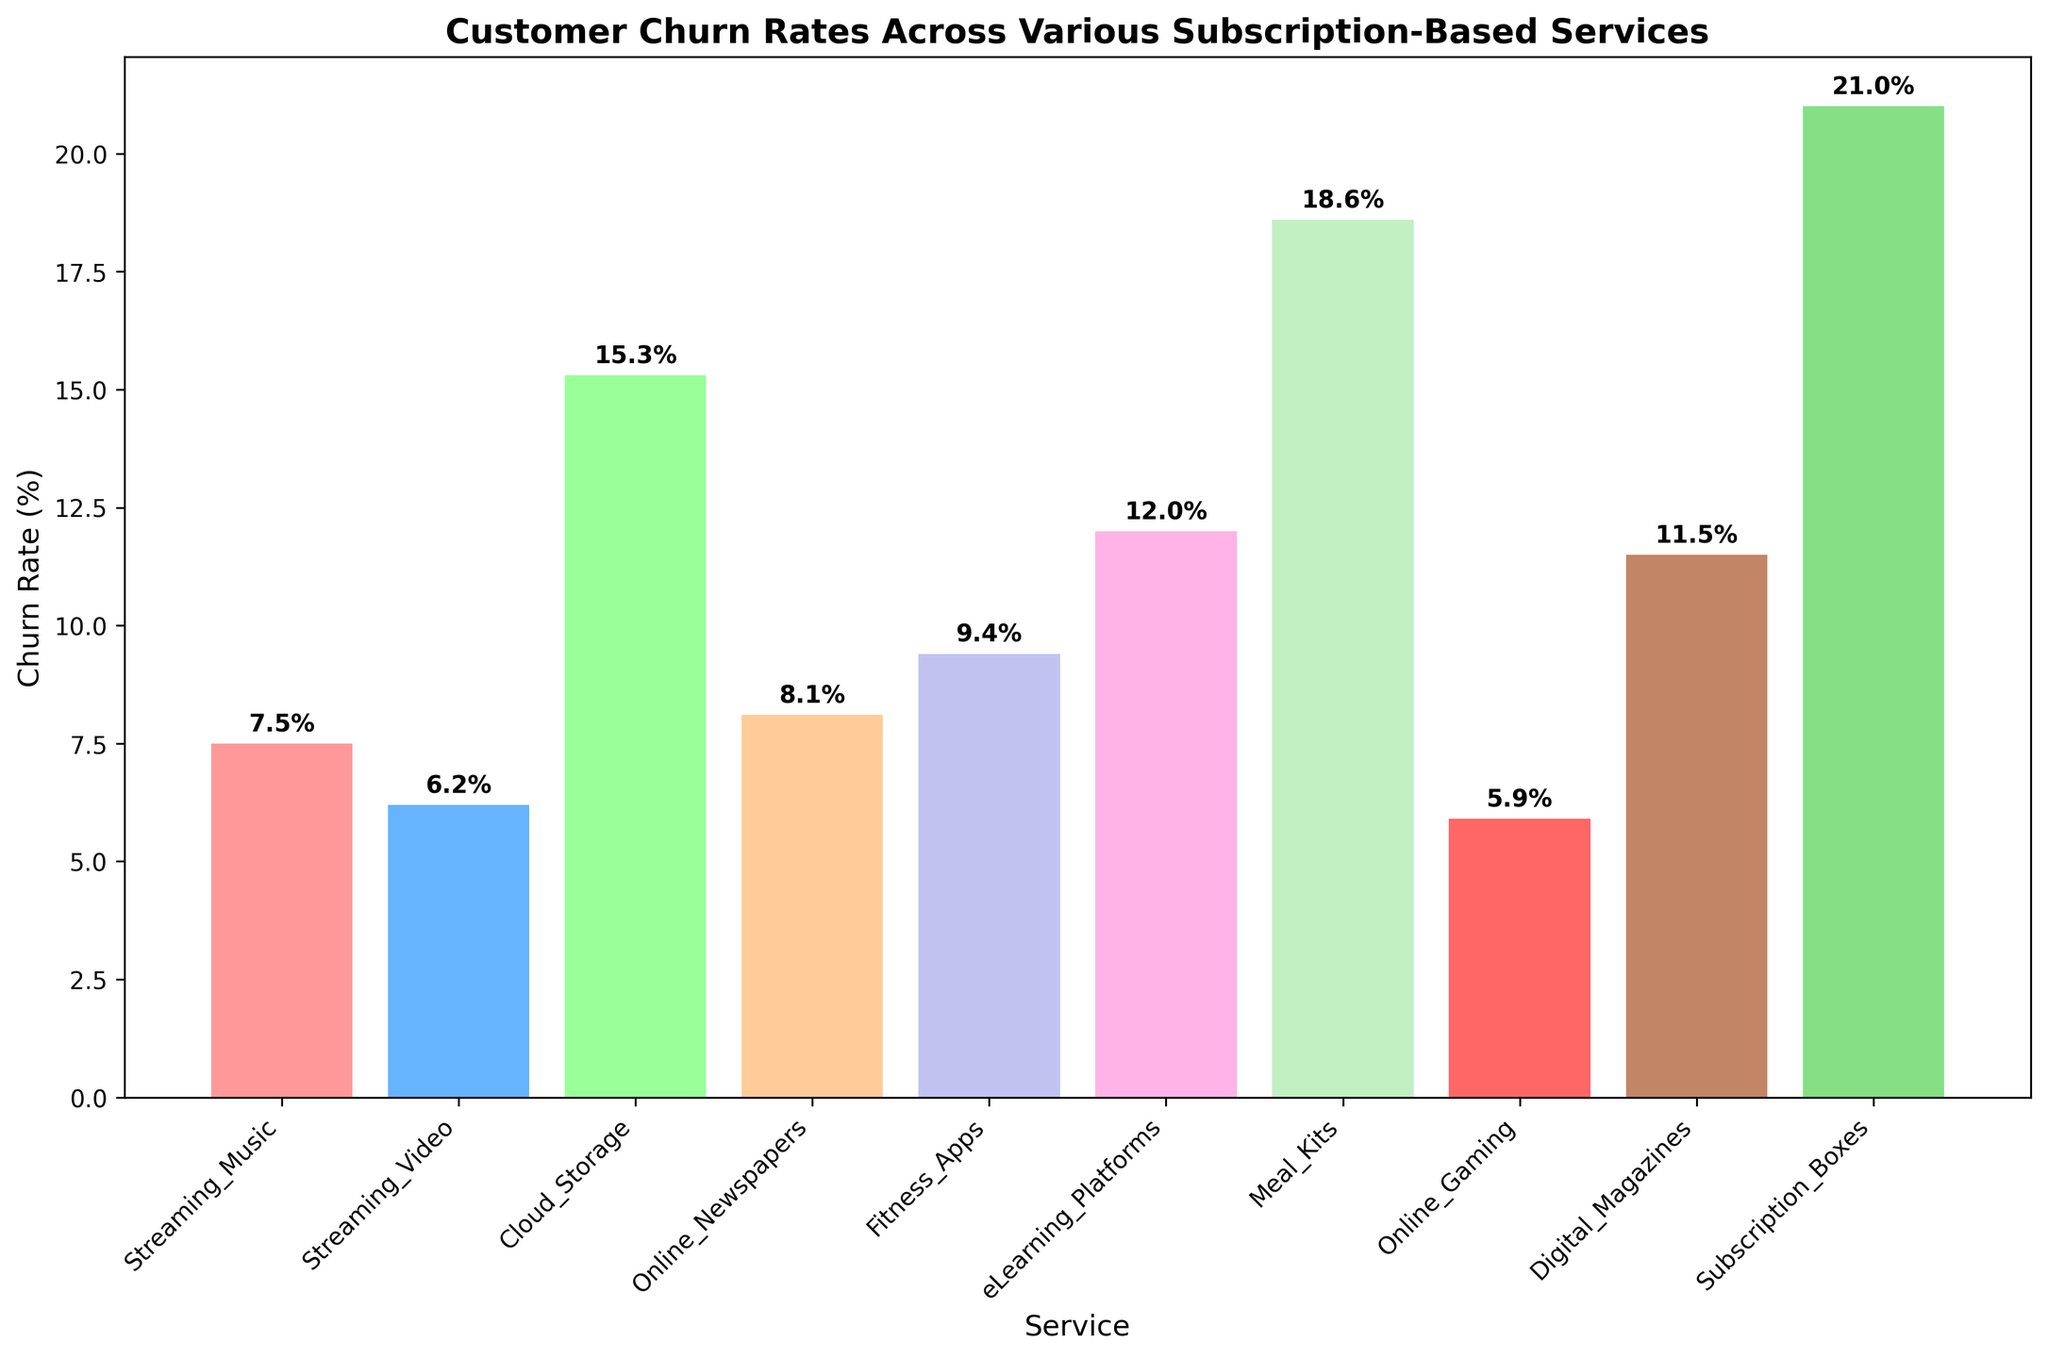What is the churn rate of the subscription service with the highest churn rate, and what is the name of that service? Look at the height of each bar and identify the tallest one, which represents the service with the highest churn rate. Then, refer to the label on the x-axis for the name of the service associated with this bar.
Answer: 21.0%, Subscription_Boxes Which subscription service has a churn rate of 5.9%? Look at the top of each bar where the churn rate is annotated. Identify the bar with a churn rate of 5.9%. Then, refer to the label on the x-axis for the name of the service associated with this bar.
Answer: Online_Gaming What is the sum of the churn rates of Cloud Storage and Streaming Music? Identify the churn rates for Cloud Storage and Streaming Music from the annotations on top of their respective bars. Add these rates together: 15.3% + 7.5%.
Answer: 22.8% Which two services have the smallest difference in their churn rates, and what is the difference? Compare the heights of the bars and identify the two bars that are closest in height. Then, subtract the smaller value from the larger one. In this case, Streaming Video (6.2%) and Online Gaming (5.9%) have the smallest difference: 6.2% - 5.9% = 0.3%.
Answer: Streaming_Video and Online_Gaming, 0.3% How does the churn rate of Fitness Apps compare to that of eLearning Platforms? Locate the bars for Fitness Apps and eLearning Platforms. Compare the height of these bars (or the numbers annotated at the top).
Answer: Fitness_Apps has a churn rate of 9.4%, which is lower than 12.0% for eLearning_Platforms What is the average churn rate of all the subscription services listed? Identify all the churn rates from the bars and sum them up: 7.5% + 6.2% + 15.3% + 8.1% + 9.4% + 12.0% + 18.6% + 5.9% + 11.5% + 21.0%. Divide this sum by the number of services, which is 10. Calculate (115.5%) / 10 = 11.55%.
Answer: 11.55% What range of colors is used to represent different services in the bar chart? Observe the different colors used in the bars. There should be a visible distinction in color between each bar representing a different service. Colors like red, blue, green, orange, purple, pink, light green, red, brown, and light green are used.
Answer: Various colors including red, blue, green, orange, purple, pink, light green, red, brown, and light green 